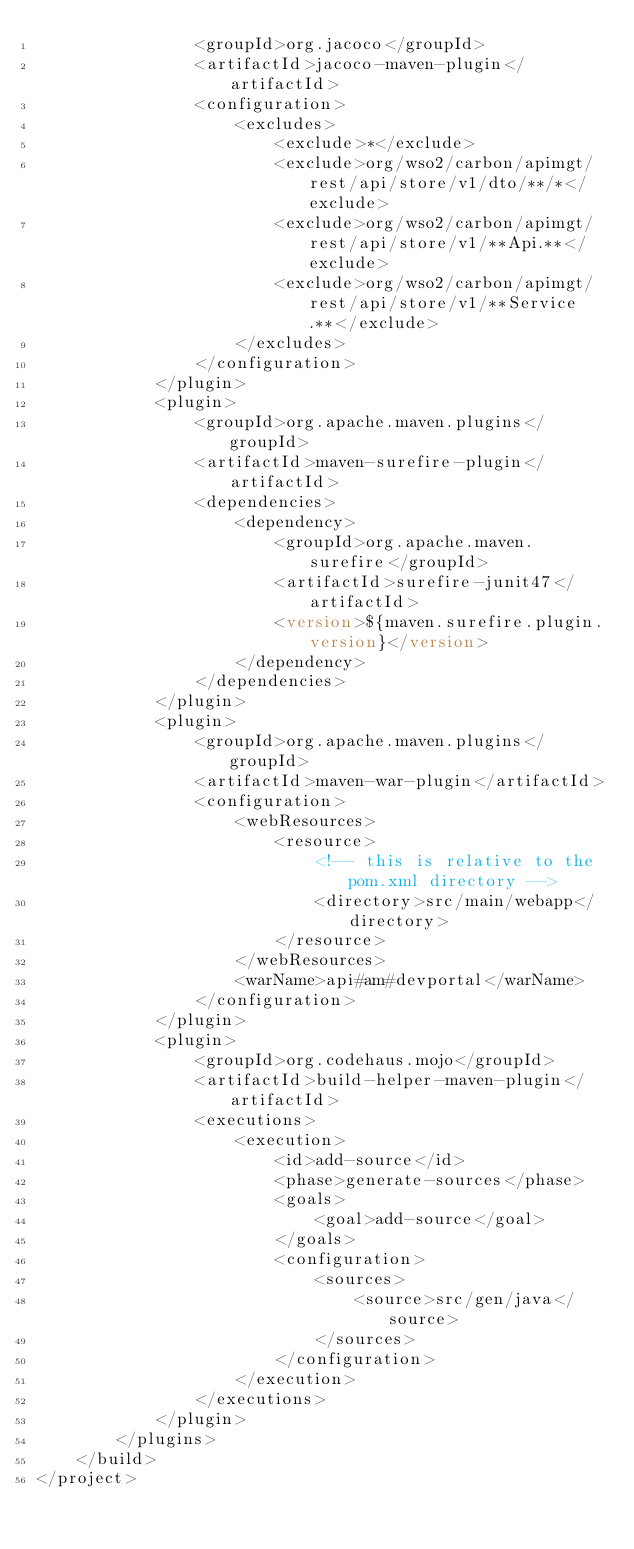<code> <loc_0><loc_0><loc_500><loc_500><_XML_>                <groupId>org.jacoco</groupId>
                <artifactId>jacoco-maven-plugin</artifactId>
                <configuration>
                    <excludes>
                        <exclude>*</exclude>
                        <exclude>org/wso2/carbon/apimgt/rest/api/store/v1/dto/**/*</exclude>
                        <exclude>org/wso2/carbon/apimgt/rest/api/store/v1/**Api.**</exclude>
                        <exclude>org/wso2/carbon/apimgt/rest/api/store/v1/**Service.**</exclude>
                    </excludes>
                </configuration>
            </plugin>
            <plugin>
                <groupId>org.apache.maven.plugins</groupId>
                <artifactId>maven-surefire-plugin</artifactId>
                <dependencies>
                    <dependency>
                        <groupId>org.apache.maven.surefire</groupId>
                        <artifactId>surefire-junit47</artifactId>
                        <version>${maven.surefire.plugin.version}</version>
                    </dependency>
                </dependencies>
            </plugin>
            <plugin>
                <groupId>org.apache.maven.plugins</groupId>
                <artifactId>maven-war-plugin</artifactId>
                <configuration>
                    <webResources>
                        <resource>
                            <!-- this is relative to the pom.xml directory -->
                            <directory>src/main/webapp</directory>
                        </resource>
                    </webResources>
                    <warName>api#am#devportal</warName>
                </configuration>
            </plugin>
            <plugin>
                <groupId>org.codehaus.mojo</groupId>
                <artifactId>build-helper-maven-plugin</artifactId>
                <executions>
                    <execution>
                        <id>add-source</id>
                        <phase>generate-sources</phase>
                        <goals>
                            <goal>add-source</goal>
                        </goals>
                        <configuration>
                            <sources>
                                <source>src/gen/java</source>
                            </sources>
                        </configuration>
                    </execution>
                </executions>
            </plugin>
        </plugins>
    </build>
</project>
</code> 